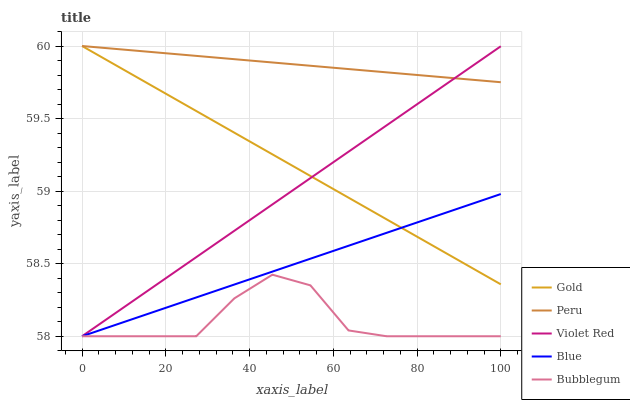Does Violet Red have the minimum area under the curve?
Answer yes or no. No. Does Violet Red have the maximum area under the curve?
Answer yes or no. No. Is Violet Red the smoothest?
Answer yes or no. No. Is Violet Red the roughest?
Answer yes or no. No. Does Peru have the lowest value?
Answer yes or no. No. Does Violet Red have the highest value?
Answer yes or no. No. Is Bubblegum less than Peru?
Answer yes or no. Yes. Is Peru greater than Bubblegum?
Answer yes or no. Yes. Does Bubblegum intersect Peru?
Answer yes or no. No. 